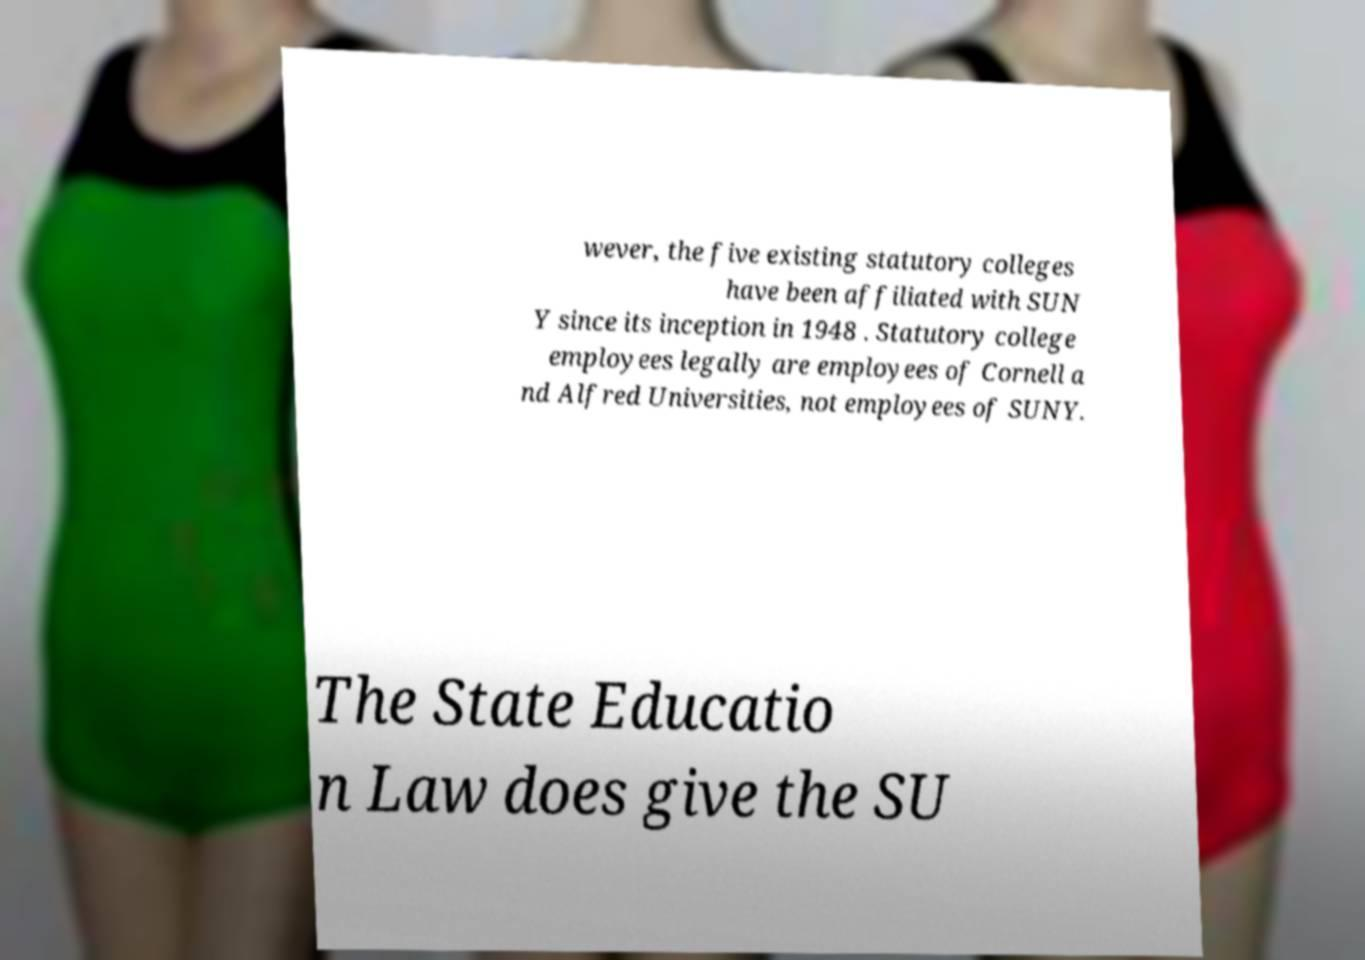I need the written content from this picture converted into text. Can you do that? wever, the five existing statutory colleges have been affiliated with SUN Y since its inception in 1948 . Statutory college employees legally are employees of Cornell a nd Alfred Universities, not employees of SUNY. The State Educatio n Law does give the SU 